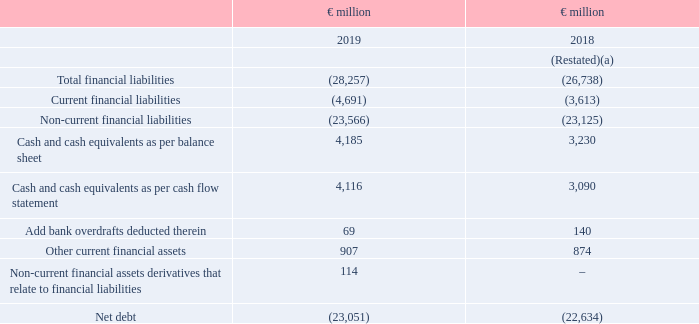Net debt
Net debt is a measure that provides valuable additional information on the summary presentation of the Group’s net financial liabilities and is a measure in common use elsewhere.
Prior to this quarter, all financial asset derivatives were current financial assets and so reduced net debt. Following a recent review we now also have financial asset derivatives that are non-current in nature. As all of these derivatives relate to financial liabilities, we continue to exclude them for the purposes of our net debt calculation and have expanded our definition to reflect this.
Net debt is now defined as the excess of total financial liabilities, excluding trade payables and other current liabilities, over cash, cash equivalents and other current financial assets, excluding trade and other current receivables, and non-current financial asset derivatives that relate to financial liabilities.
(a) Restated following adoption of IFRS 16. See note 1 and note 24 for further details.
What is Net Debt? Net debt is a measure that provides valuable additional information on the summary presentation of the group’s net financial liabilities and is a measure in common use elsewhere. How is Net Debt calculated? Excess of total financial liabilities, excluding trade payables and other current liabilities, over cash, cash equivalents and other current financial assets. What is excluded from Net Debt calculation? Trade and other current receivables, and non-current financial asset derivatives that relate to financial liabilities. What is the average total financial liabilities?
Answer scale should be: million. - (28,257 + 26,738) / 2
Answer: -27497.5. What is the change in the Cash and cash equivalents as per balance sheet from 2018 to 2019?
Answer scale should be: million. (4,185 - 3,230)
Answer: 955. What is the percentage change in Net Debt?
Answer scale should be: percent. (23,051 / 22,634) - 1
Answer: 1.84. 